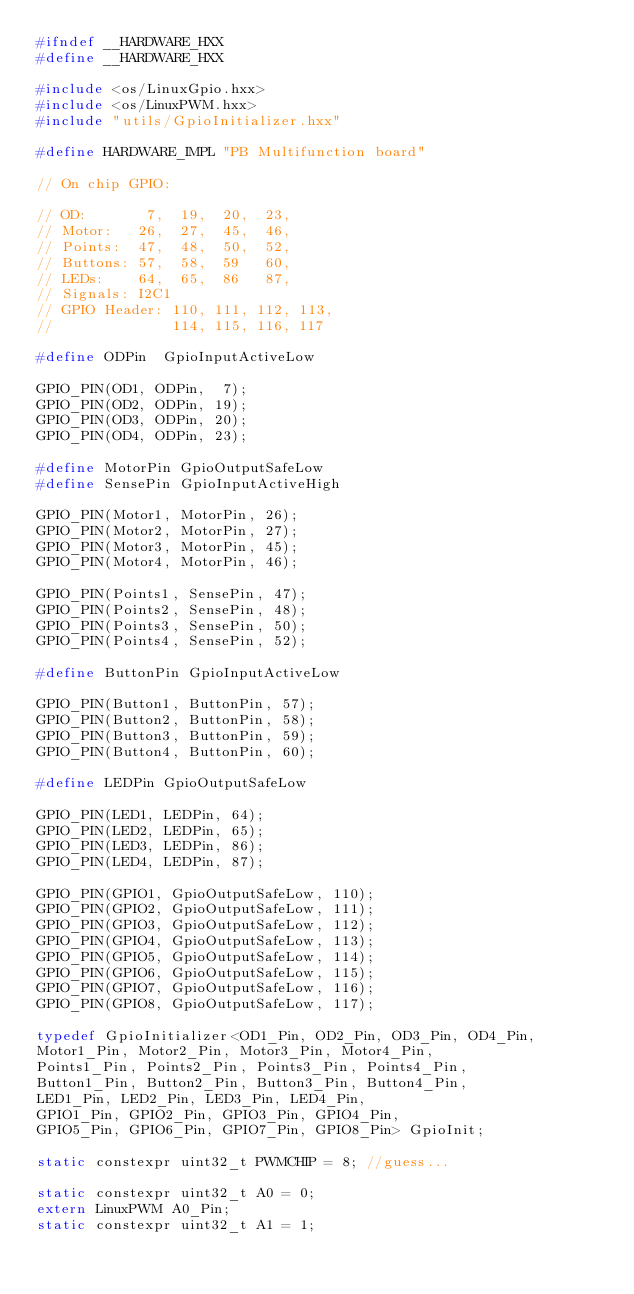Convert code to text. <code><loc_0><loc_0><loc_500><loc_500><_C++_>#ifndef __HARDWARE_HXX
#define __HARDWARE_HXX

#include <os/LinuxGpio.hxx>
#include <os/LinuxPWM.hxx>
#include "utils/GpioInitializer.hxx"

#define HARDWARE_IMPL "PB Multifunction board"

// On chip GPIO:

// OD:       7,  19,  20,  23,
// Motor:   26,  27,  45,  46,
// Points:  47,  48,  50,  52,
// Buttons: 57,  58,  59   60,
// LEDs:    64,  65,  86   87,
// Signals: I2C1
// GPIO Header: 110, 111, 112, 113,
//              114, 115, 116, 117

#define ODPin  GpioInputActiveLow

GPIO_PIN(OD1, ODPin,  7);
GPIO_PIN(OD2, ODPin, 19);
GPIO_PIN(OD3, ODPin, 20);
GPIO_PIN(OD4, ODPin, 23);

#define MotorPin GpioOutputSafeLow
#define SensePin GpioInputActiveHigh

GPIO_PIN(Motor1, MotorPin, 26);
GPIO_PIN(Motor2, MotorPin, 27);
GPIO_PIN(Motor3, MotorPin, 45);
GPIO_PIN(Motor4, MotorPin, 46);

GPIO_PIN(Points1, SensePin, 47);
GPIO_PIN(Points2, SensePin, 48);
GPIO_PIN(Points3, SensePin, 50);
GPIO_PIN(Points4, SensePin, 52);

#define ButtonPin GpioInputActiveLow

GPIO_PIN(Button1, ButtonPin, 57);
GPIO_PIN(Button2, ButtonPin, 58);
GPIO_PIN(Button3, ButtonPin, 59);
GPIO_PIN(Button4, ButtonPin, 60);

#define LEDPin GpioOutputSafeLow

GPIO_PIN(LED1, LEDPin, 64);
GPIO_PIN(LED2, LEDPin, 65);
GPIO_PIN(LED3, LEDPin, 86);
GPIO_PIN(LED4, LEDPin, 87);

GPIO_PIN(GPIO1, GpioOutputSafeLow, 110);
GPIO_PIN(GPIO2, GpioOutputSafeLow, 111);
GPIO_PIN(GPIO3, GpioOutputSafeLow, 112);
GPIO_PIN(GPIO4, GpioOutputSafeLow, 113);
GPIO_PIN(GPIO5, GpioOutputSafeLow, 114);
GPIO_PIN(GPIO6, GpioOutputSafeLow, 115);
GPIO_PIN(GPIO7, GpioOutputSafeLow, 116);
GPIO_PIN(GPIO8, GpioOutputSafeLow, 117);

typedef GpioInitializer<OD1_Pin, OD2_Pin, OD3_Pin, OD4_Pin,
Motor1_Pin, Motor2_Pin, Motor3_Pin, Motor4_Pin,
Points1_Pin, Points2_Pin, Points3_Pin, Points4_Pin,
Button1_Pin, Button2_Pin, Button3_Pin, Button4_Pin,
LED1_Pin, LED2_Pin, LED3_Pin, LED4_Pin,
GPIO1_Pin, GPIO2_Pin, GPIO3_Pin, GPIO4_Pin,
GPIO5_Pin, GPIO6_Pin, GPIO7_Pin, GPIO8_Pin> GpioInit;

static constexpr uint32_t PWMCHIP = 8; //guess...

static constexpr uint32_t A0 = 0;
extern LinuxPWM A0_Pin;
static constexpr uint32_t A1 = 1;</code> 